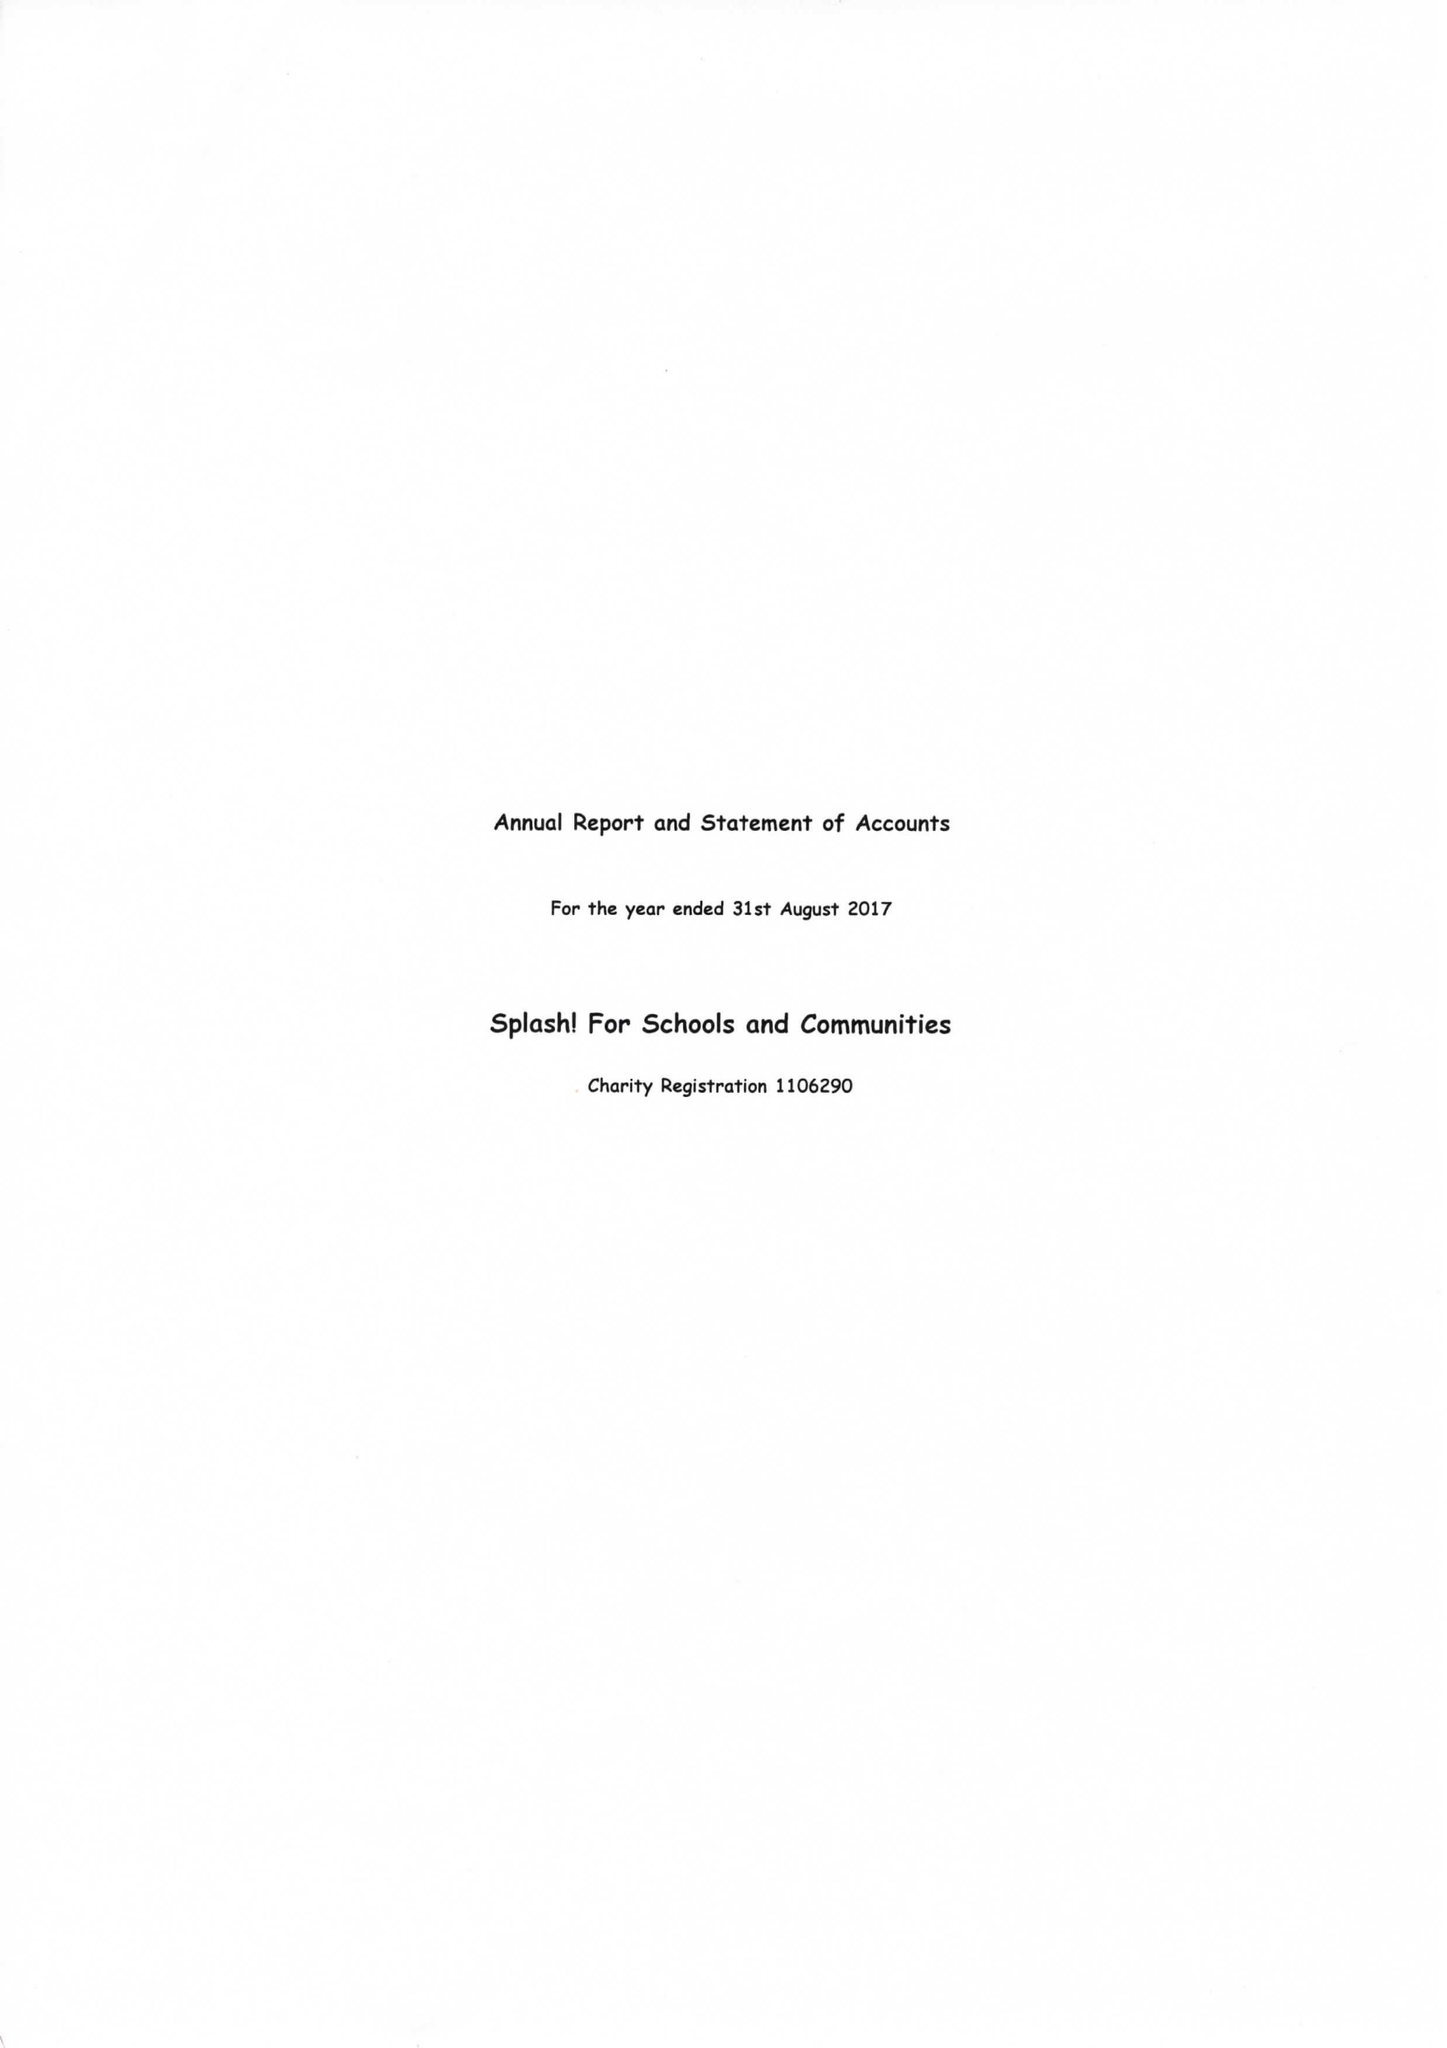What is the value for the charity_name?
Answer the question using a single word or phrase. Splash For Schools and Communities 